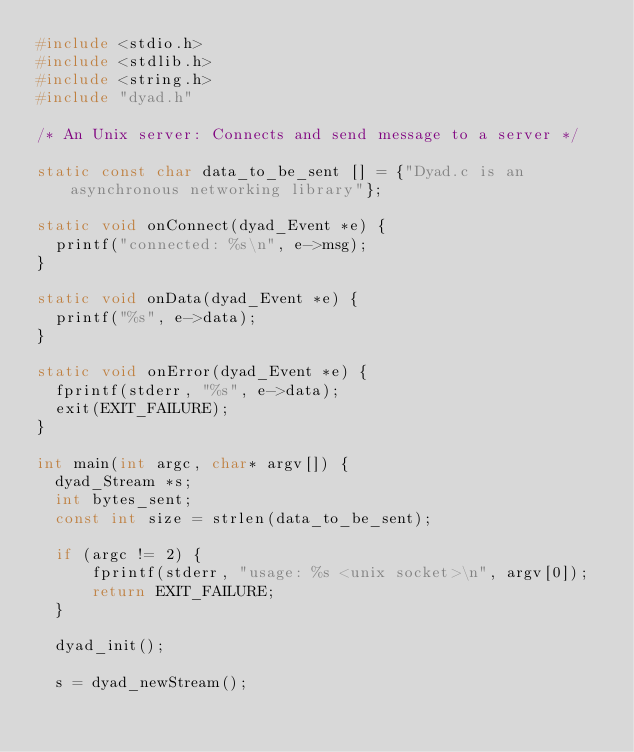<code> <loc_0><loc_0><loc_500><loc_500><_C_>#include <stdio.h>
#include <stdlib.h>
#include <string.h>
#include "dyad.h"

/* An Unix server: Connects and send message to a server */

static const char data_to_be_sent [] = {"Dyad.c is an asynchronous networking library"};

static void onConnect(dyad_Event *e) {
  printf("connected: %s\n", e->msg);
}

static void onData(dyad_Event *e) {
  printf("%s", e->data);
}

static void onError(dyad_Event *e) {
  fprintf(stderr, "%s", e->data);
  exit(EXIT_FAILURE);
}

int main(int argc, char* argv[]) {
  dyad_Stream *s;
  int bytes_sent;
  const int size = strlen(data_to_be_sent);

  if (argc != 2) {
      fprintf(stderr, "usage: %s <unix socket>\n", argv[0]);
      return EXIT_FAILURE;
  }

  dyad_init();

  s = dyad_newStream();</code> 